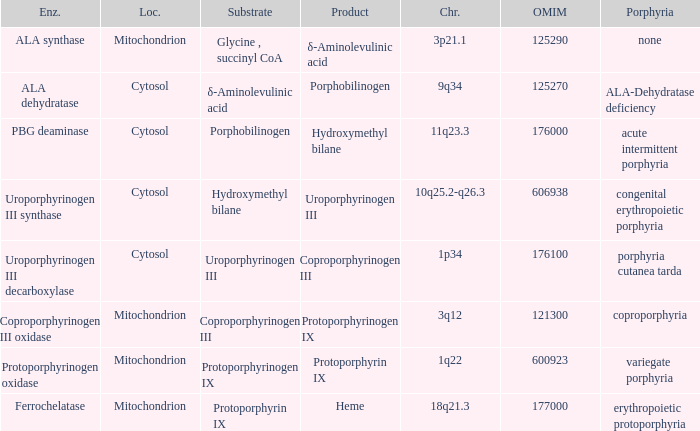What is the location of the enzyme Uroporphyrinogen iii Synthase? Cytosol. 